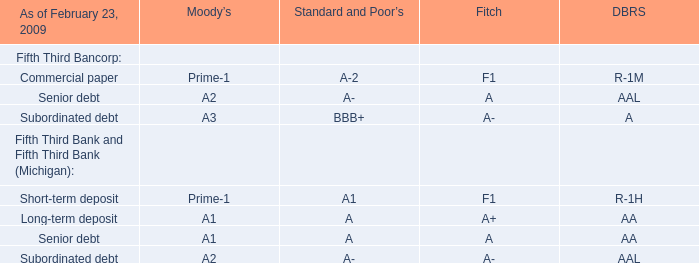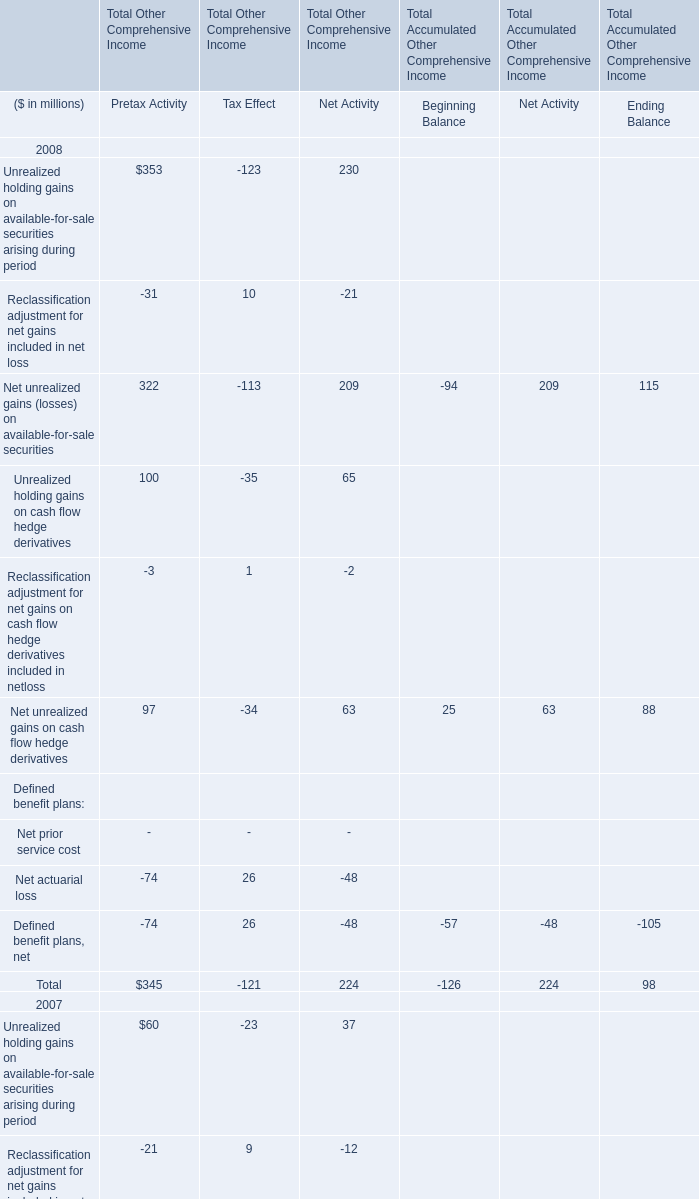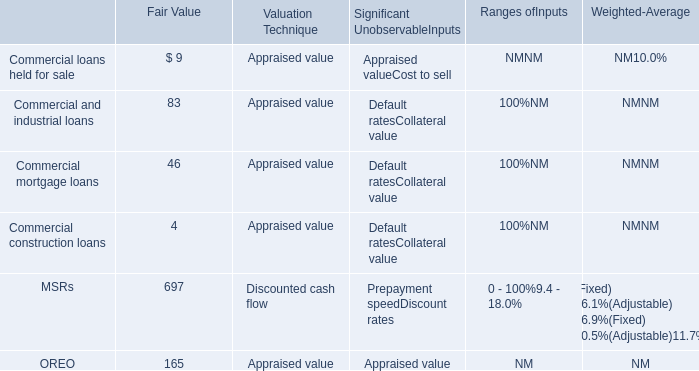what is the percentage change in nonrecurring losses from 2012 to 2013? 
Computations: ((19 - 17) / 17)
Answer: 0.11765. 